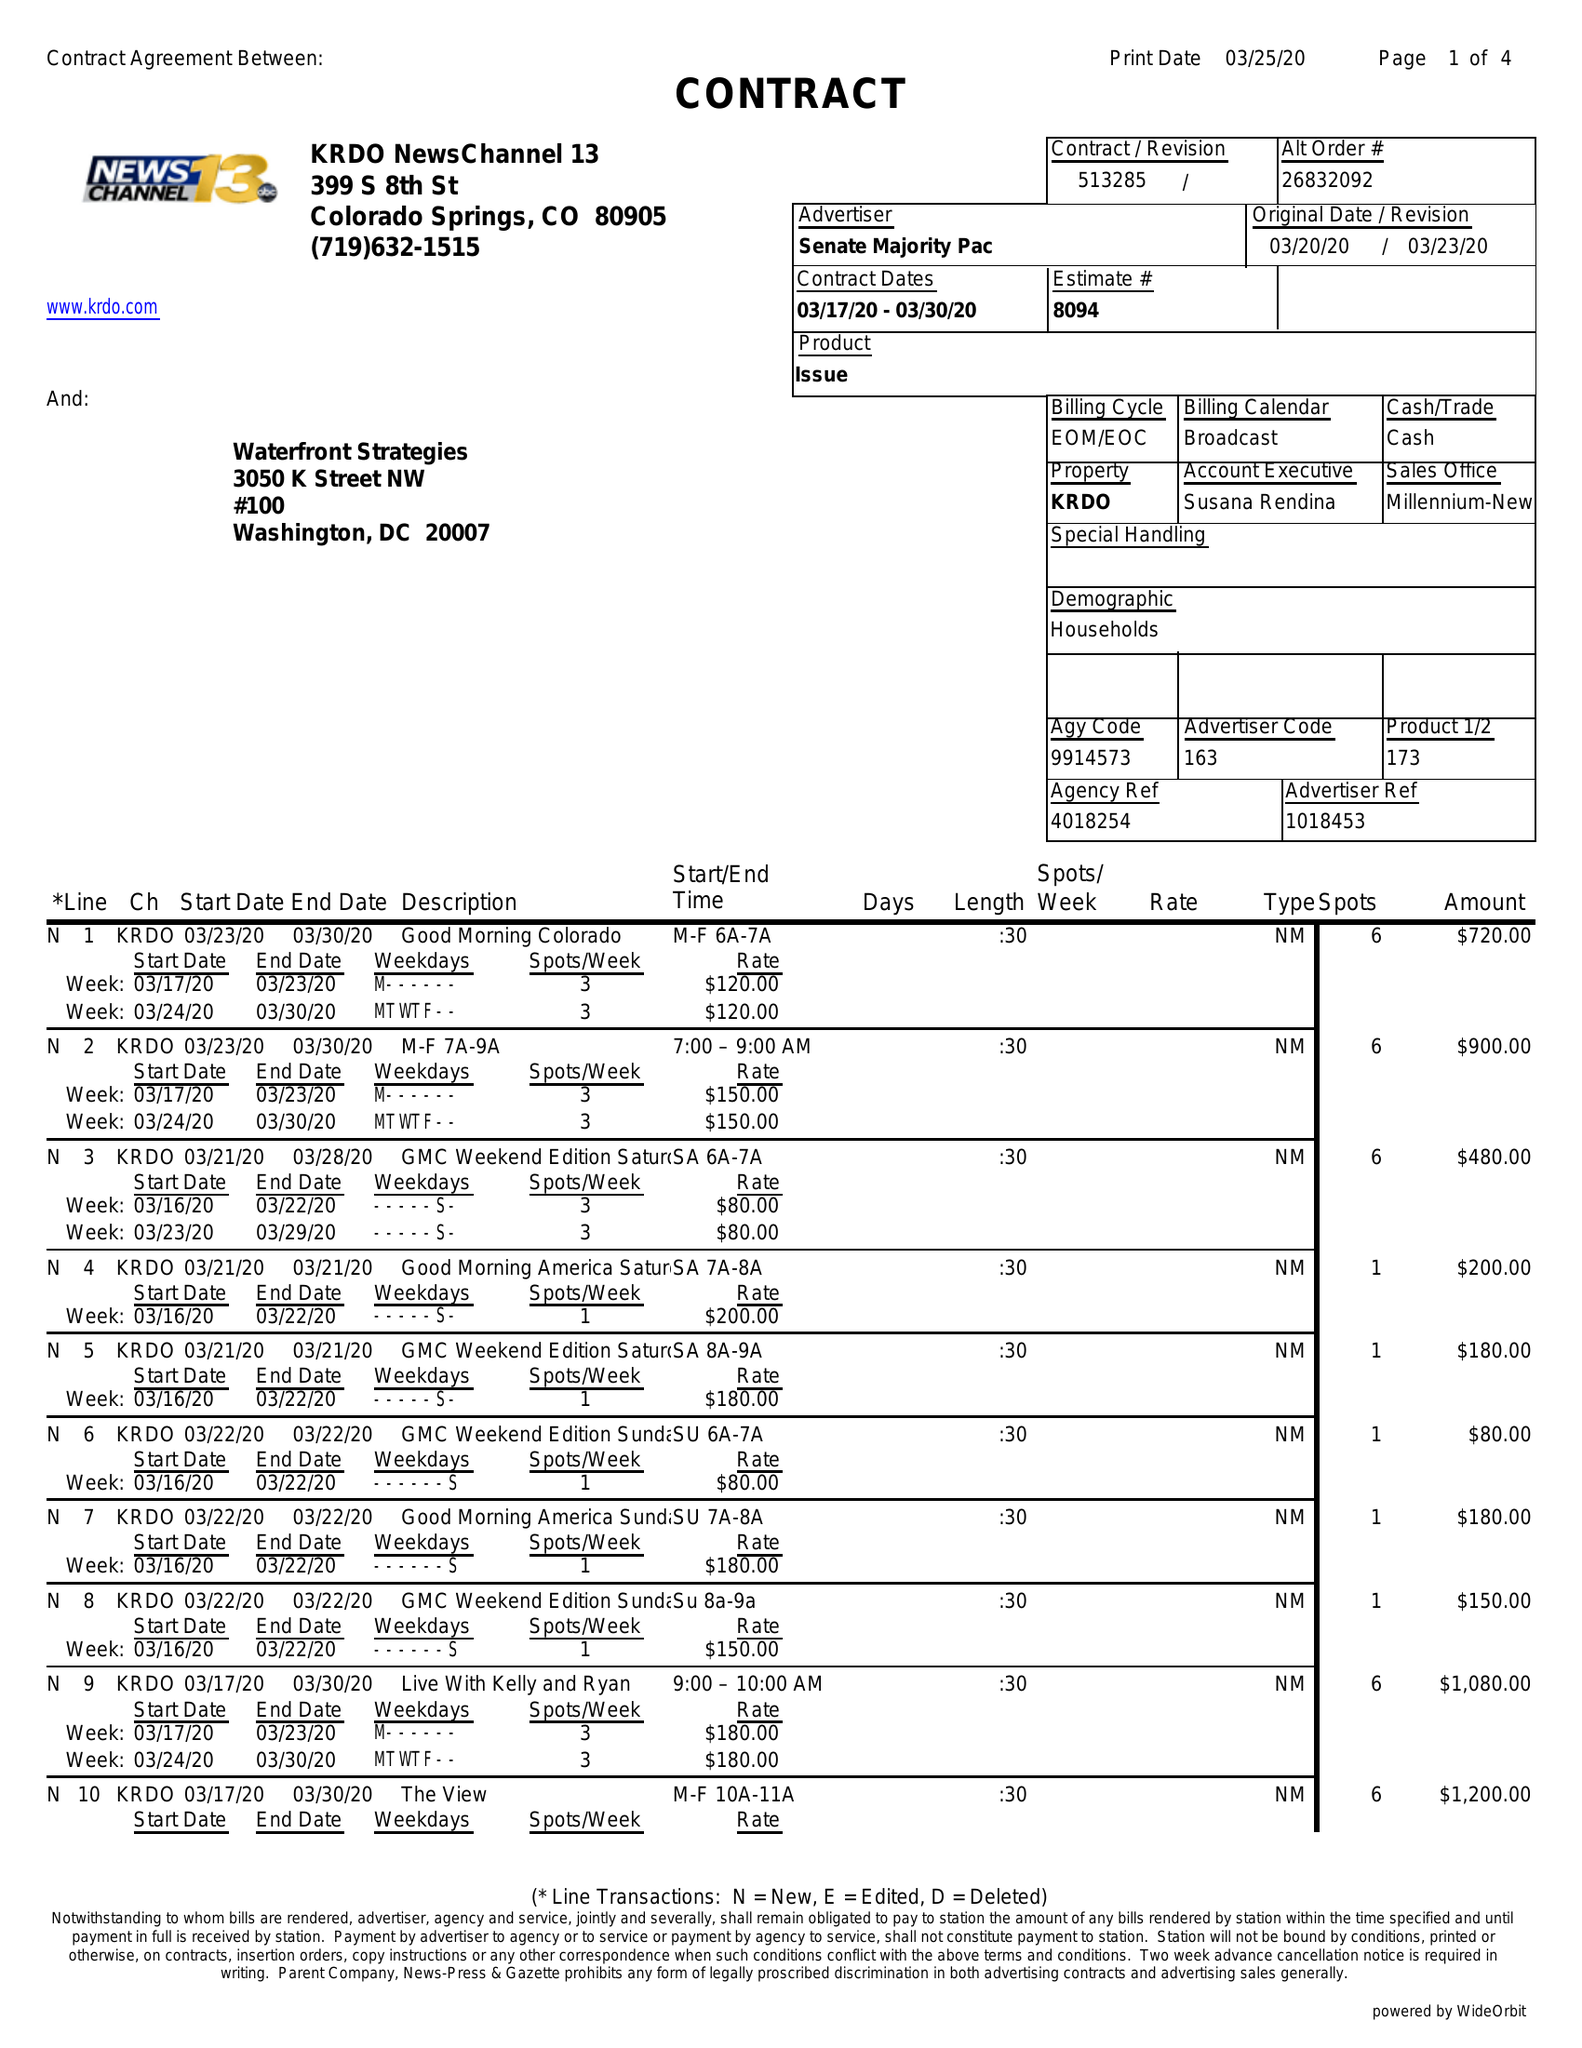What is the value for the advertiser?
Answer the question using a single word or phrase. SENATE MAJORITY PAC 